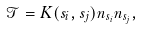Convert formula to latex. <formula><loc_0><loc_0><loc_500><loc_500>\mathcal { T } = K ( s _ { i } , s _ { j } ) n _ { s _ { i } } n _ { s _ { j } } ,</formula> 